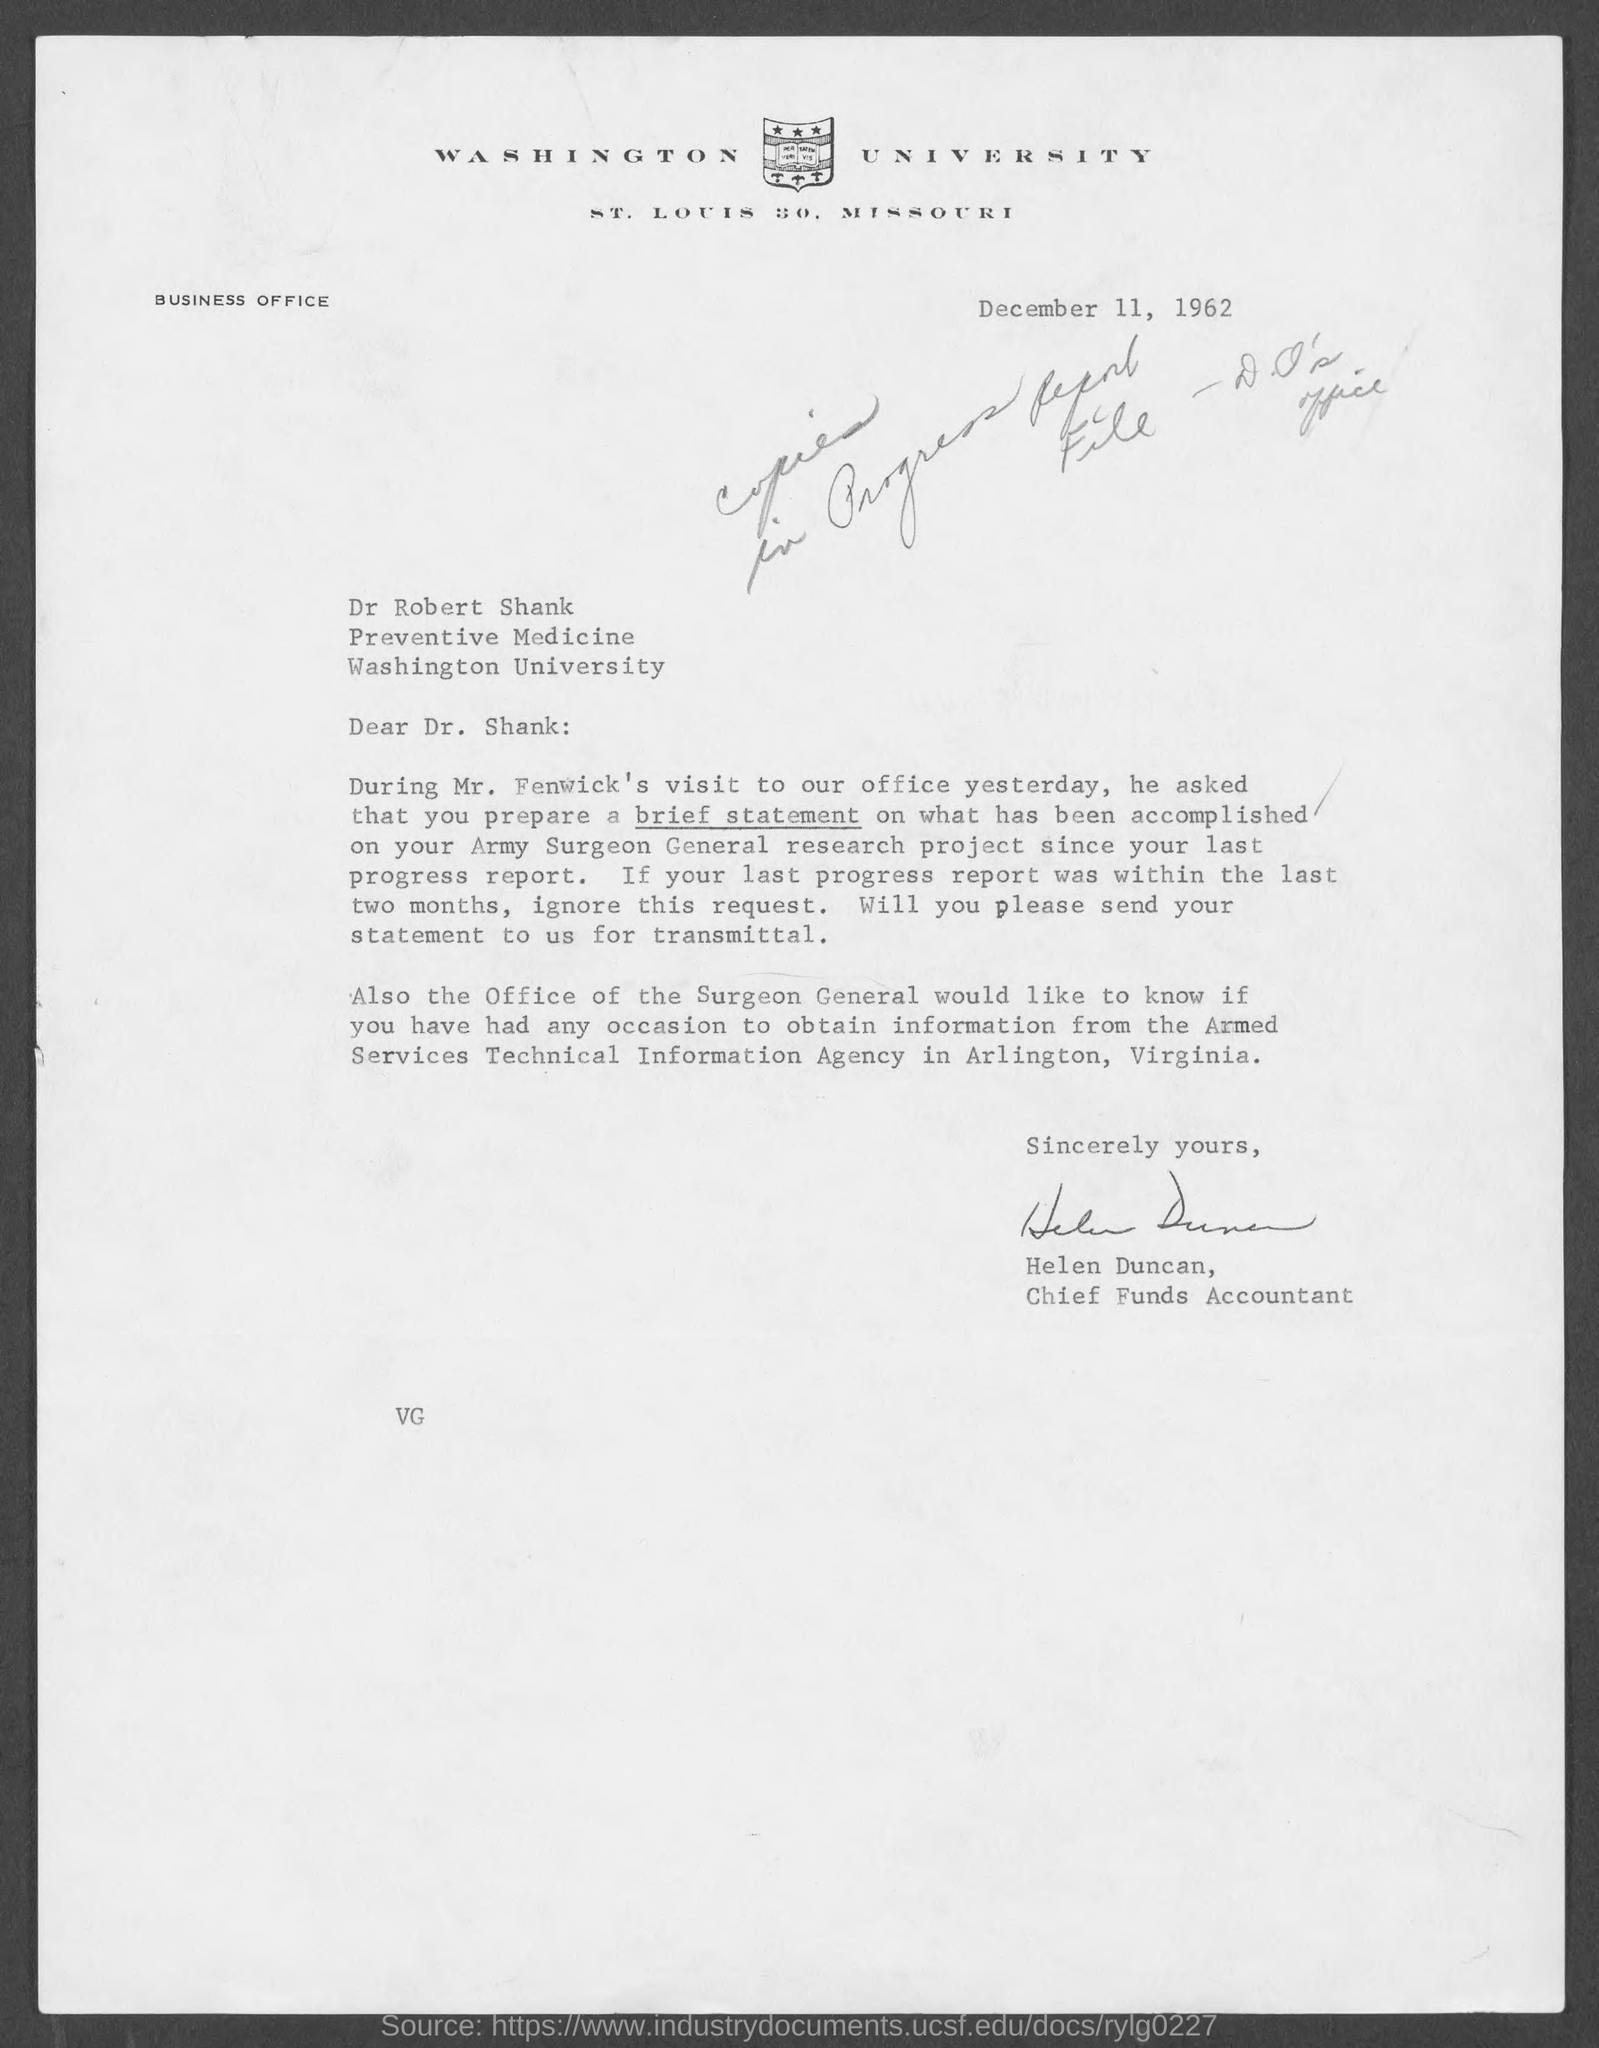When is the document dated?
Ensure brevity in your answer.  December 11, 1962. Who is the sender?
Keep it short and to the point. Helen Duncan. Who is Helen Duncan?
Provide a short and direct response. Chief Funds Accountant. 